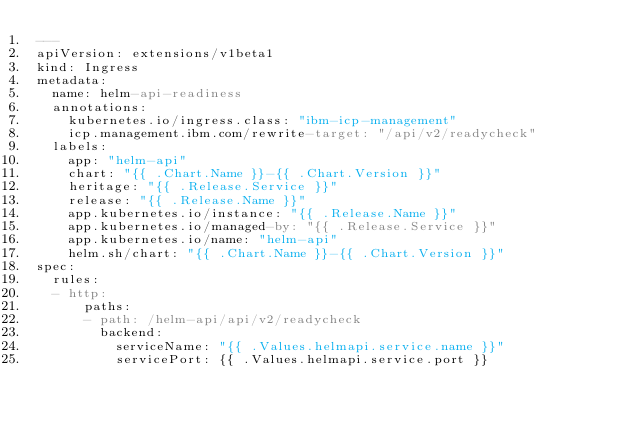<code> <loc_0><loc_0><loc_500><loc_500><_YAML_>---
apiVersion: extensions/v1beta1
kind: Ingress
metadata:
  name: helm-api-readiness
  annotations:
    kubernetes.io/ingress.class: "ibm-icp-management"
    icp.management.ibm.com/rewrite-target: "/api/v2/readycheck"
  labels:
    app: "helm-api"
    chart: "{{ .Chart.Name }}-{{ .Chart.Version }}"
    heritage: "{{ .Release.Service }}"
    release: "{{ .Release.Name }}"
    app.kubernetes.io/instance: "{{ .Release.Name }}"
    app.kubernetes.io/managed-by: "{{ .Release.Service }}"
    app.kubernetes.io/name: "helm-api"
    helm.sh/chart: "{{ .Chart.Name }}-{{ .Chart.Version }}"
spec:
  rules:
  - http:
      paths:
      - path: /helm-api/api/v2/readycheck
        backend:
          serviceName: "{{ .Values.helmapi.service.name }}"
          servicePort: {{ .Values.helmapi.service.port }}
</code> 